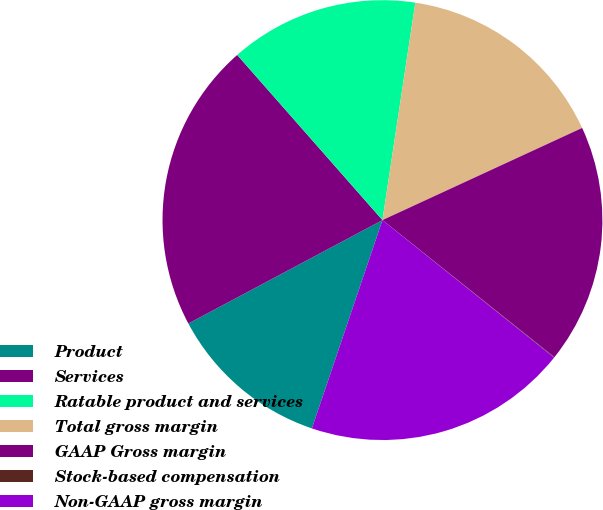Convert chart. <chart><loc_0><loc_0><loc_500><loc_500><pie_chart><fcel>Product<fcel>Services<fcel>Ratable product and services<fcel>Total gross margin<fcel>GAAP Gross margin<fcel>Stock-based compensation<fcel>Non-GAAP gross margin<nl><fcel>12.01%<fcel>21.31%<fcel>13.87%<fcel>15.73%<fcel>17.59%<fcel>0.04%<fcel>19.45%<nl></chart> 